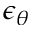<formula> <loc_0><loc_0><loc_500><loc_500>\epsilon _ { \theta }</formula> 